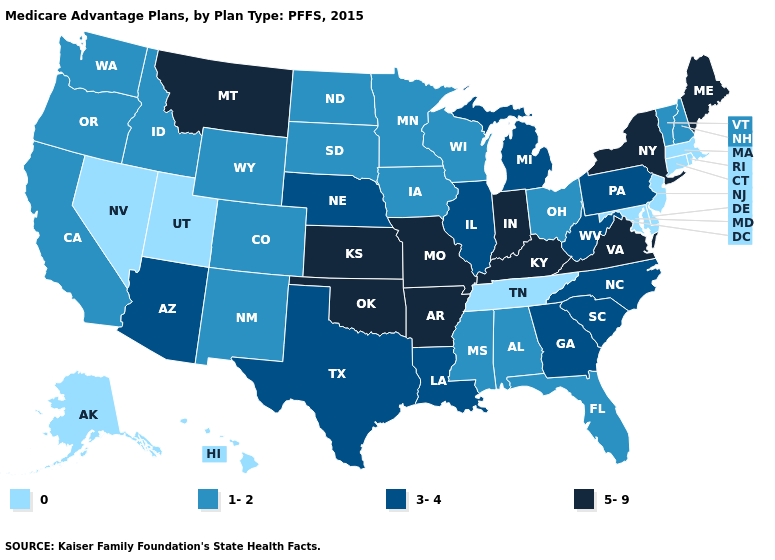Name the states that have a value in the range 5-9?
Answer briefly. Arkansas, Indiana, Kansas, Kentucky, Maine, Missouri, Montana, New York, Oklahoma, Virginia. Among the states that border Illinois , does Wisconsin have the lowest value?
Answer briefly. Yes. Does the first symbol in the legend represent the smallest category?
Keep it brief. Yes. Which states have the lowest value in the Northeast?
Concise answer only. Connecticut, Massachusetts, New Jersey, Rhode Island. What is the value of Maine?
Write a very short answer. 5-9. What is the value of Kansas?
Concise answer only. 5-9. Does the map have missing data?
Give a very brief answer. No. What is the lowest value in states that border Illinois?
Answer briefly. 1-2. Does the first symbol in the legend represent the smallest category?
Quick response, please. Yes. What is the highest value in the MidWest ?
Give a very brief answer. 5-9. Does the first symbol in the legend represent the smallest category?
Quick response, please. Yes. Does Vermont have the lowest value in the USA?
Keep it brief. No. Name the states that have a value in the range 3-4?
Answer briefly. Arizona, Georgia, Illinois, Louisiana, Michigan, North Carolina, Nebraska, Pennsylvania, South Carolina, Texas, West Virginia. What is the highest value in the USA?
Short answer required. 5-9. 